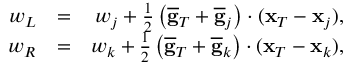Convert formula to latex. <formula><loc_0><loc_0><loc_500><loc_500>\begin{array} { r l r } { w _ { L } } & { = } & { w _ { j } + \frac { 1 } { 2 } \left ( \overline { g } _ { T } + \overline { g } _ { j } \right ) \cdot ( { x } _ { T } - { x } _ { j } ) , } \\ { w _ { R } } & { = } & { w _ { k } + \frac { 1 } { 2 } \left ( \overline { g } _ { T } + \overline { g } _ { k } \right ) \cdot ( { x } _ { T } - { x } _ { k } ) , } \end{array}</formula> 